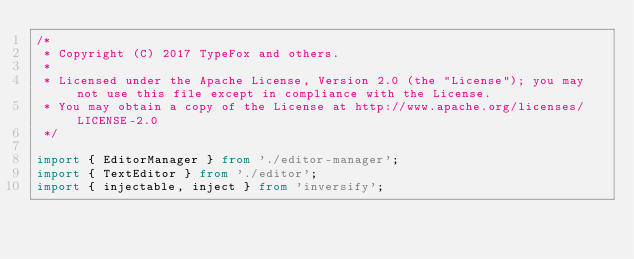<code> <loc_0><loc_0><loc_500><loc_500><_TypeScript_>/*
 * Copyright (C) 2017 TypeFox and others.
 *
 * Licensed under the Apache License, Version 2.0 (the "License"); you may not use this file except in compliance with the License.
 * You may obtain a copy of the License at http://www.apache.org/licenses/LICENSE-2.0
 */

import { EditorManager } from './editor-manager';
import { TextEditor } from './editor';
import { injectable, inject } from 'inversify';</code> 